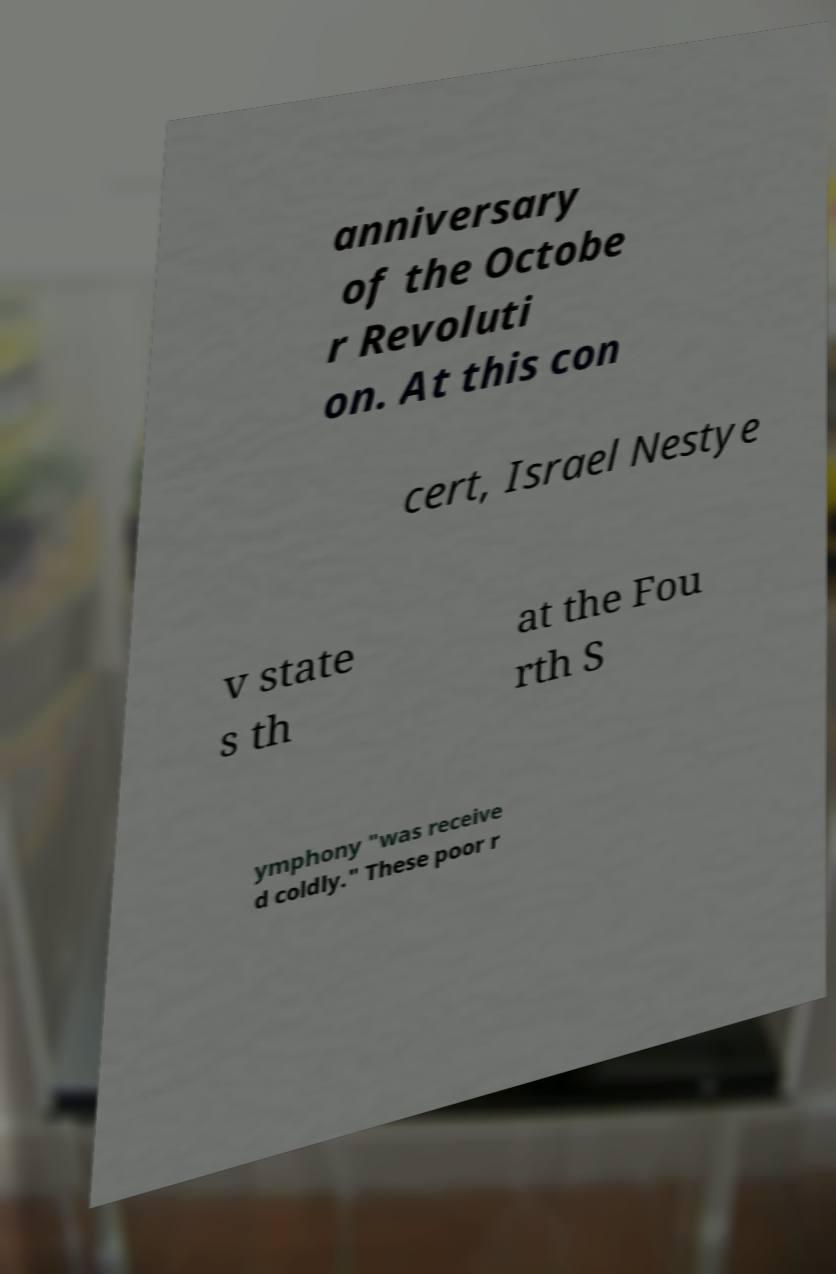I need the written content from this picture converted into text. Can you do that? anniversary of the Octobe r Revoluti on. At this con cert, Israel Nestye v state s th at the Fou rth S ymphony "was receive d coldly." These poor r 